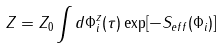<formula> <loc_0><loc_0><loc_500><loc_500>Z = Z _ { 0 } \int d \Phi _ { i } ^ { z } ( \tau ) \exp [ - S _ { e f f } ( \Phi _ { i } ) ]</formula> 